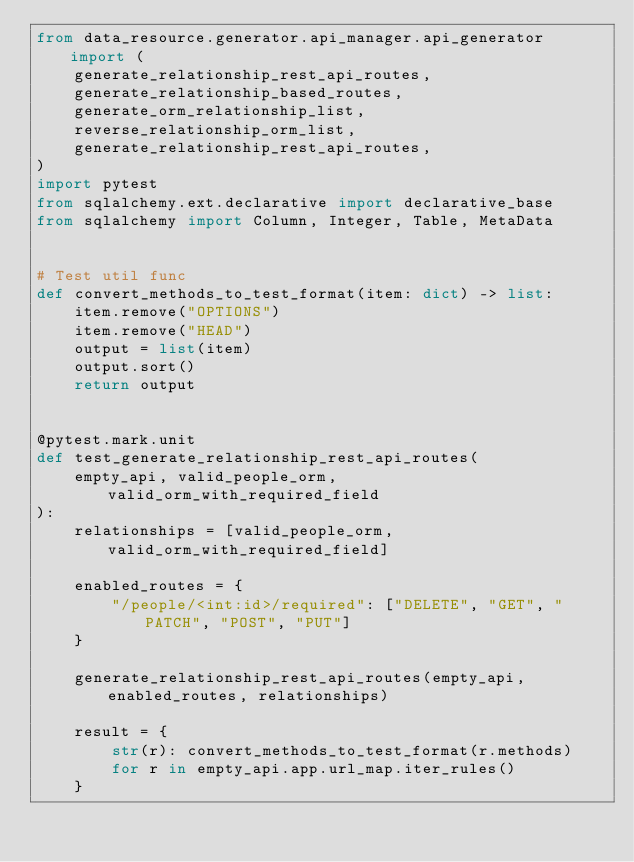Convert code to text. <code><loc_0><loc_0><loc_500><loc_500><_Python_>from data_resource.generator.api_manager.api_generator import (
    generate_relationship_rest_api_routes,
    generate_relationship_based_routes,
    generate_orm_relationship_list,
    reverse_relationship_orm_list,
    generate_relationship_rest_api_routes,
)
import pytest
from sqlalchemy.ext.declarative import declarative_base
from sqlalchemy import Column, Integer, Table, MetaData


# Test util func
def convert_methods_to_test_format(item: dict) -> list:
    item.remove("OPTIONS")
    item.remove("HEAD")
    output = list(item)
    output.sort()
    return output


@pytest.mark.unit
def test_generate_relationship_rest_api_routes(
    empty_api, valid_people_orm, valid_orm_with_required_field
):
    relationships = [valid_people_orm, valid_orm_with_required_field]

    enabled_routes = {
        "/people/<int:id>/required": ["DELETE", "GET", "PATCH", "POST", "PUT"]
    }

    generate_relationship_rest_api_routes(empty_api, enabled_routes, relationships)

    result = {
        str(r): convert_methods_to_test_format(r.methods)
        for r in empty_api.app.url_map.iter_rules()
    }
</code> 